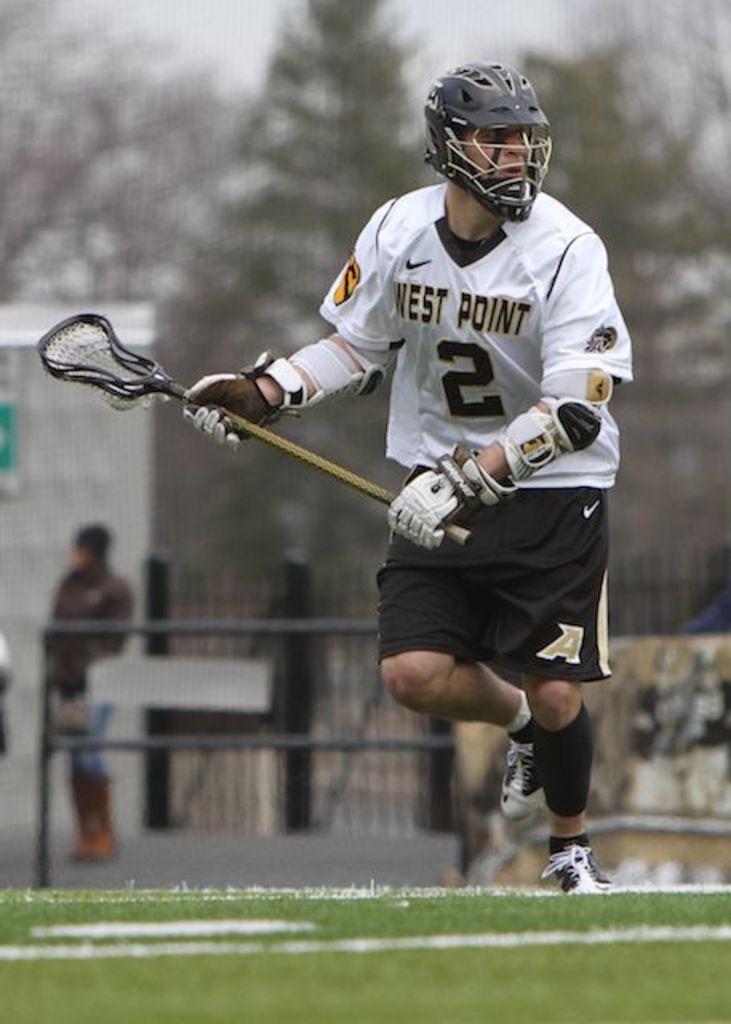Could you give a brief overview of what you see in this image? In the center of the image we can see a man holding a stick. In the background there is a fence and we can see a person. On the left there is a shed and there are trees. At the top there is sky. 